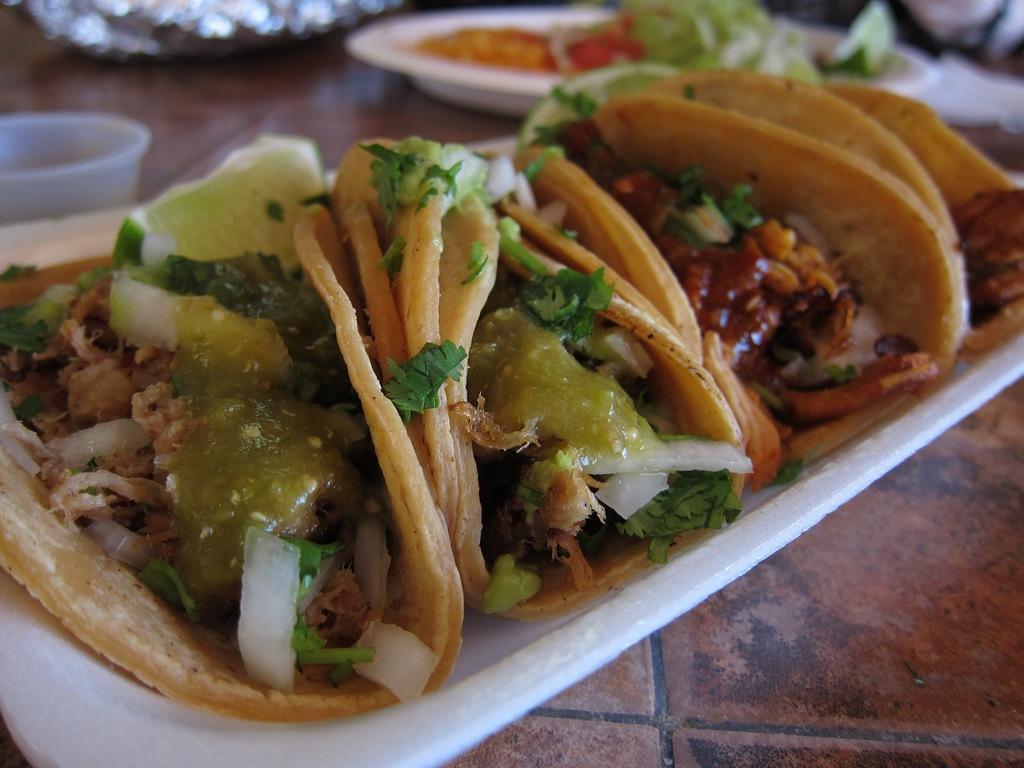How would you summarize this image in a sentence or two? In this image there is a plate on which there are tacos. Beside the plate there is another plate in which there is some food. On the left side there is a plastic bowl on the table. 